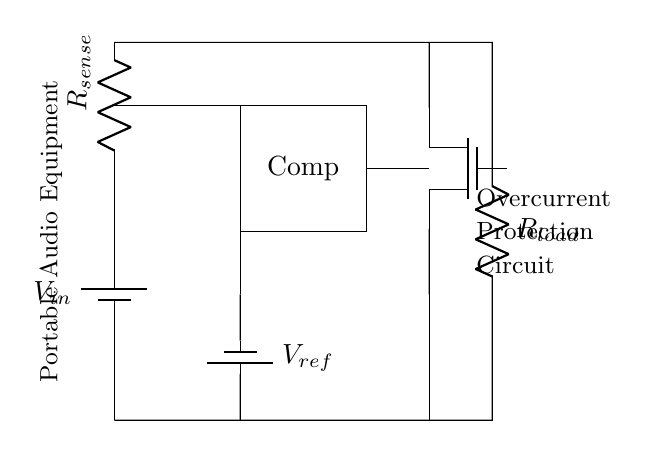What is the reference voltage in the circuit? The circuit includes a component labeled as a reference voltage, specifically a battery connected to the comparator. The label shows this component as being identified with $V_{ref}$.
Answer: V_ref What type of transistor is used for overcurrent protection? The circuit diagram displays a transistor labeled as Tnmos, indicating that a N-channel MOSFET is utilized for the overcurrent protection mechanism. This information is presented in the component notation within the circuit.
Answer: MOSFET How many resistors are present in the circuit? In the circuit, two resistors can be identified: the current sense resistor labeled as $R_{sense}$ and the load resistor labeled as $R_{load}$. Therefore, by counting both labeled components, we conclude that there are two resistors.
Answer: 2 What is the role of the comparator in this circuit? The comparator's purpose is to compare the sensing voltage from $R_{sense}$ with the reference voltage $V_{ref}$. If the sensed voltage exceeds the reference voltage, it triggers the MOSFET to disconnect the load, providing overcurrent protection.
Answer: Overcurrent detection Where is the portable audio equipment connected in this circuit? The circuit shows that the portable audio equipment is connected at the input and the output of the load resistor, which denotes its position in relation to the power supply and the overall function of the circuit as a part of the load.
Answer: At R_load What is the primary function of $R_{sense}$? The $R_{sense}$ resistor is responsible for monitoring the current flowing through the load by creating a voltage drop that can be compared to the reference voltage. This allows the circuit to detect overcurrent conditions.
Answer: Current monitoring 